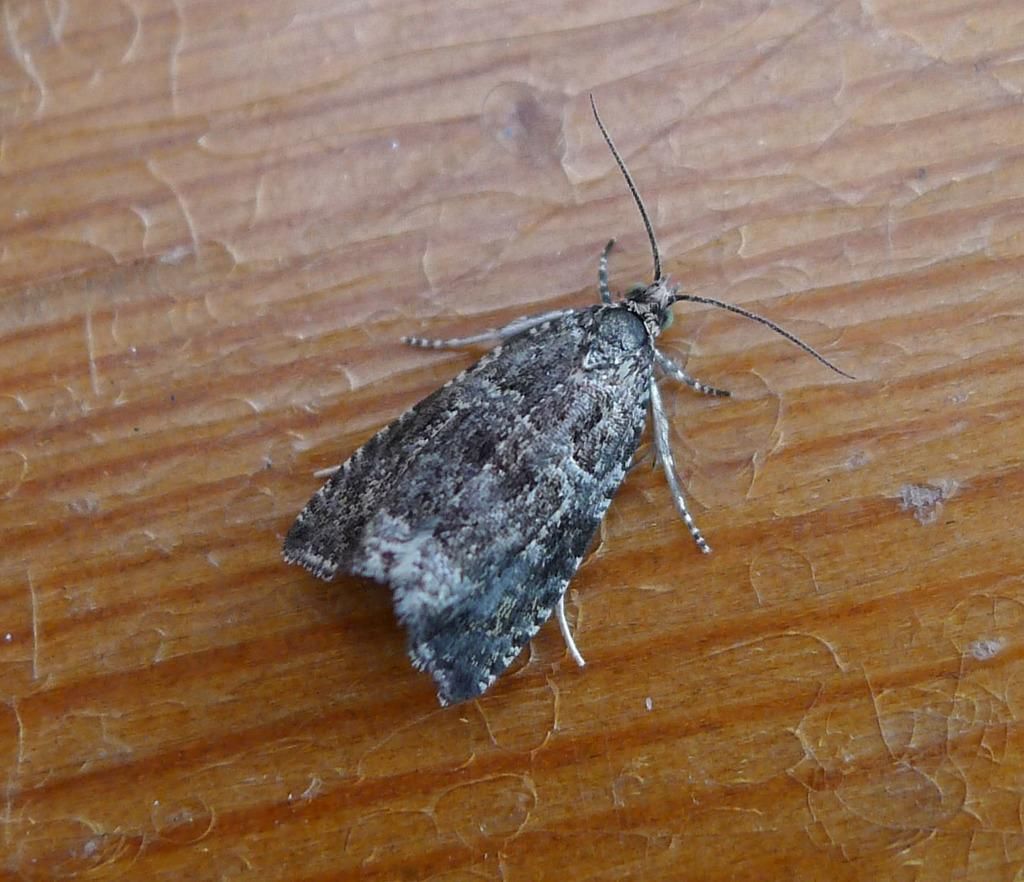What type of creature can be seen in the image? There is an insect in the image. Where is the insect located in the image? The insect is on a surface. How many cats are interacting with the insect in the image? There are no cats present in the image; it only features an insect on a surface. Is there a volcano erupting in the background of the image? There is no volcano or any indication of an eruption in the image; it only features an insect on a surface. 